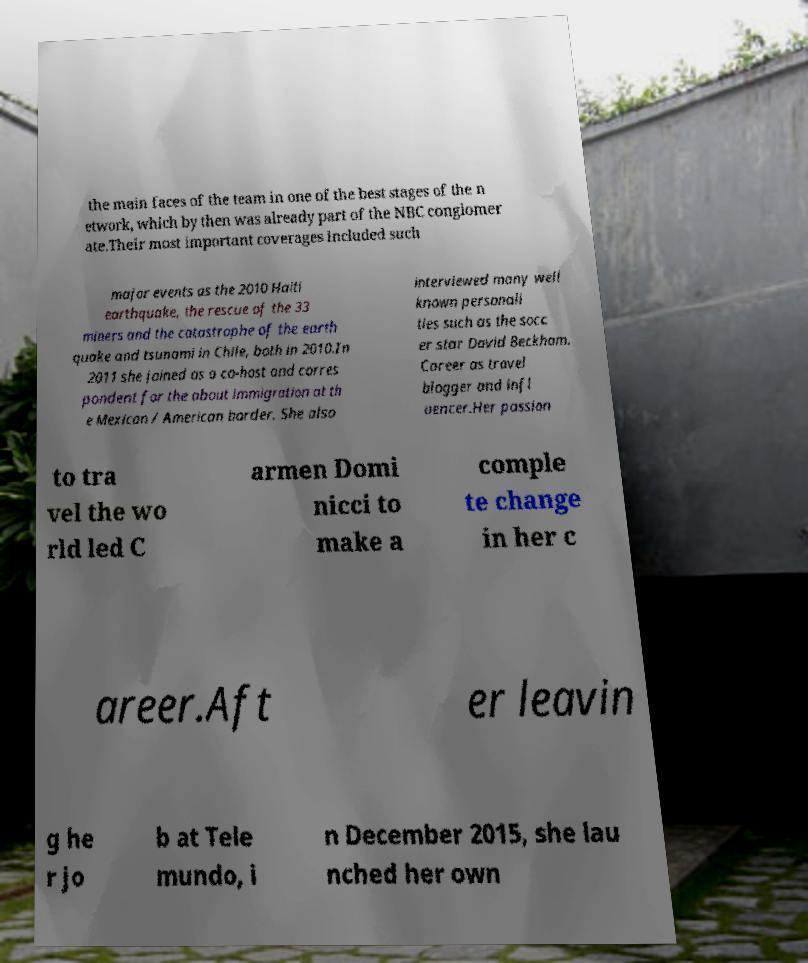Please identify and transcribe the text found in this image. the main faces of the team in one of the best stages of the n etwork, which by then was already part of the NBC conglomer ate.Their most important coverages included such major events as the 2010 Haiti earthquake, the rescue of the 33 miners and the catastrophe of the earth quake and tsunami in Chile, both in 2010.In 2011 she joined as a co-host and corres pondent for the about immigration at th e Mexican / American border. She also interviewed many well known personali ties such as the socc er star David Beckham. Career as travel blogger and infl uencer.Her passion to tra vel the wo rld led C armen Domi nicci to make a comple te change in her c areer.Aft er leavin g he r jo b at Tele mundo, i n December 2015, she lau nched her own 